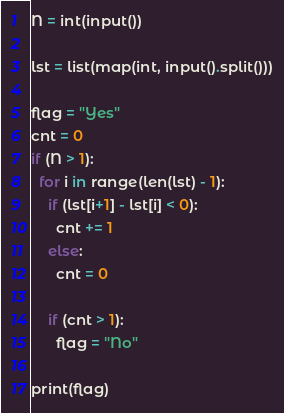<code> <loc_0><loc_0><loc_500><loc_500><_Python_>N = int(input())

lst = list(map(int, input().split()))

flag = "Yes"
cnt = 0
if (N > 1):
  for i in range(len(lst) - 1):
    if (lst[i+1] - lst[i] < 0):
      cnt += 1
    else:
      cnt = 0
      
    if (cnt > 1):
      flag = "No"

print(flag)</code> 